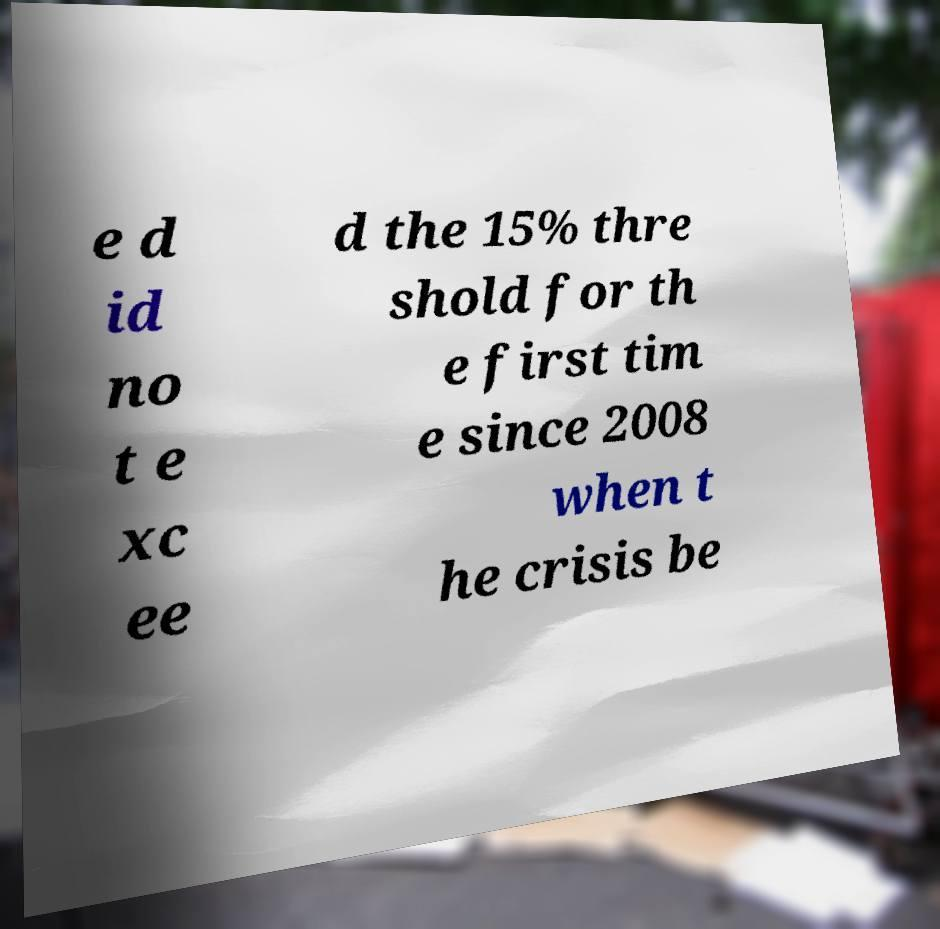Please identify and transcribe the text found in this image. e d id no t e xc ee d the 15% thre shold for th e first tim e since 2008 when t he crisis be 